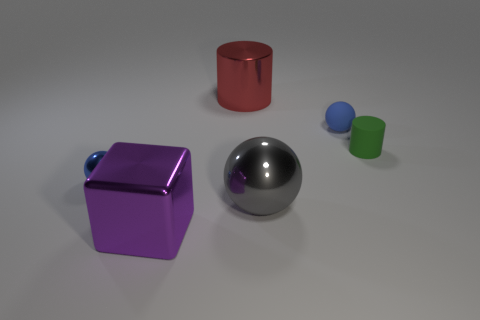Add 3 large metallic things. How many objects exist? 9 Subtract all cylinders. How many objects are left? 4 Subtract 0 gray blocks. How many objects are left? 6 Subtract all small blue shiny balls. Subtract all big blue metal spheres. How many objects are left? 5 Add 2 large purple objects. How many large purple objects are left? 3 Add 1 red metal cylinders. How many red metal cylinders exist? 2 